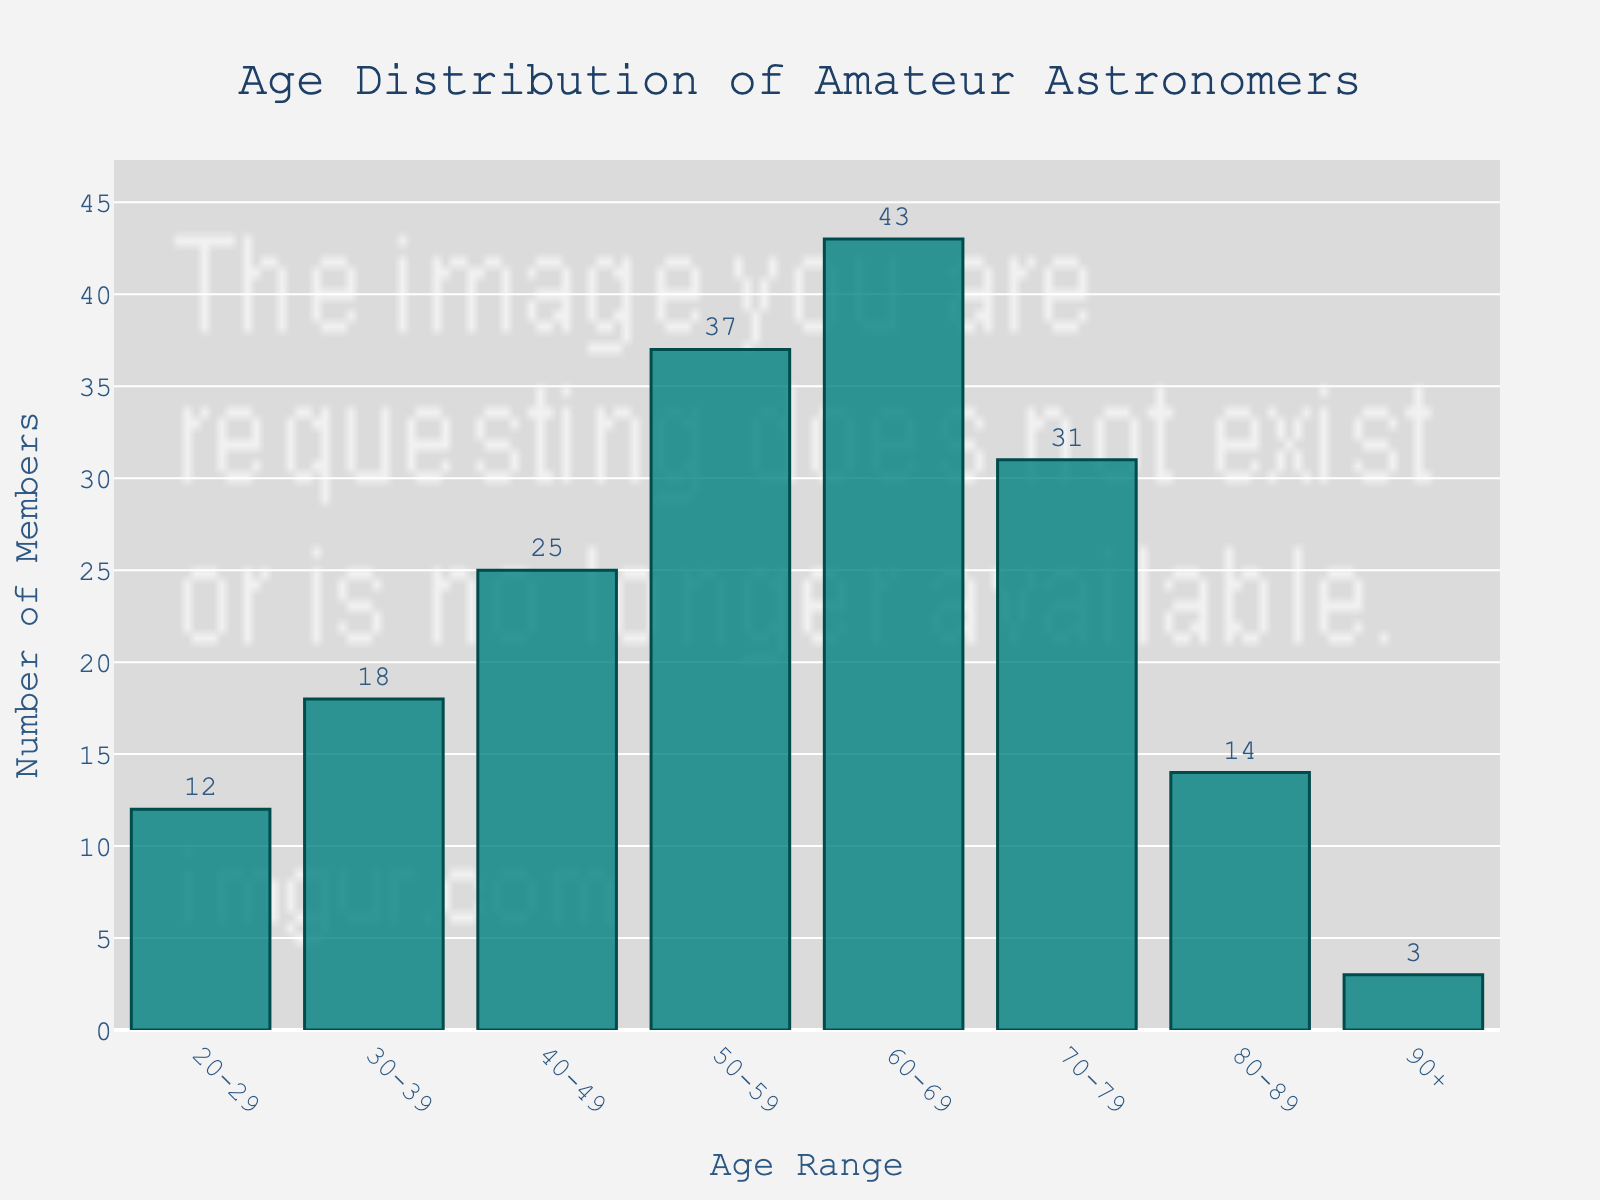What is the age range with the highest number of members? The bar with the greatest height represents the age range with the highest number of members. In this chart, it is the bar for the age range of 60-69, which has 43 members.
Answer: 60-69 Which age range has the fewest members? The bar with the smallest height represents the age range with the fewest members. In this chart, it is the age range of 90+, which has 3 members.
Answer: 90+ What is the total number of members between 50 and 79 years old? Add the number of members in the age ranges 50-59 (37), 60-69 (43), and 70-79 (31). The sum is 37 + 43 + 31 = 111.
Answer: 111 How many more members are in the age range 60-69 compared to the age range 40-49? Subtract the number of members in the age range 40-49 (25) from the number of members in the age range 60-69 (43). The difference is 43 - 25 = 18.
Answer: 18 Which age ranges have more than 30 members? Identify all bars on the chart that exceed the value of 30 on the y-axis. The age ranges with more than 30 members are 50-59 (37), 60-69 (43), and 70-79 (31).
Answer: 50-59, 60-69, 70-79 What is the average number of members in the age ranges 20-29 and 30-39? Add the number of members in the age ranges 20-29 (12) and 30-39 (18), then divide by 2. The calculation is (12 + 18) / 2 = 15.
Answer: 15 Is the number of members aged 60-69 greater than the combined members aged 20-29 and 90+? Add the members in the age ranges 20-29 (12) and 90+ (3), then compare it to the members aged 60-69 (43). The combined number is 12 + 3 = 15, which is less than 43.
Answer: Yes What is the difference in number of members between the age ranges 80-89 and 90+? Subtract the number of members in the age range 90+ (3) from the number of members in the age range 80-89 (14). The difference is 14 - 3 = 11.
Answer: 11 Which two consecutive age ranges have the largest increase in members? Calculate the difference in members between consecutive age ranges: 30-39 to 40-49 (18 to 25 = 7), 40-49 to 50-59 (25 to 37 = 12), 50-59 to 60-69 (37 to 43 = 6), 60-69 to 70-79 (43 to 31 = -12), 70-79 to 80-89 (31 to 14 = -17), and 80-89 to 90+ (14 to 3 = -11). The largest increase is between 40-49 and 50-59 (12).
Answer: 40-49 to 50-59 